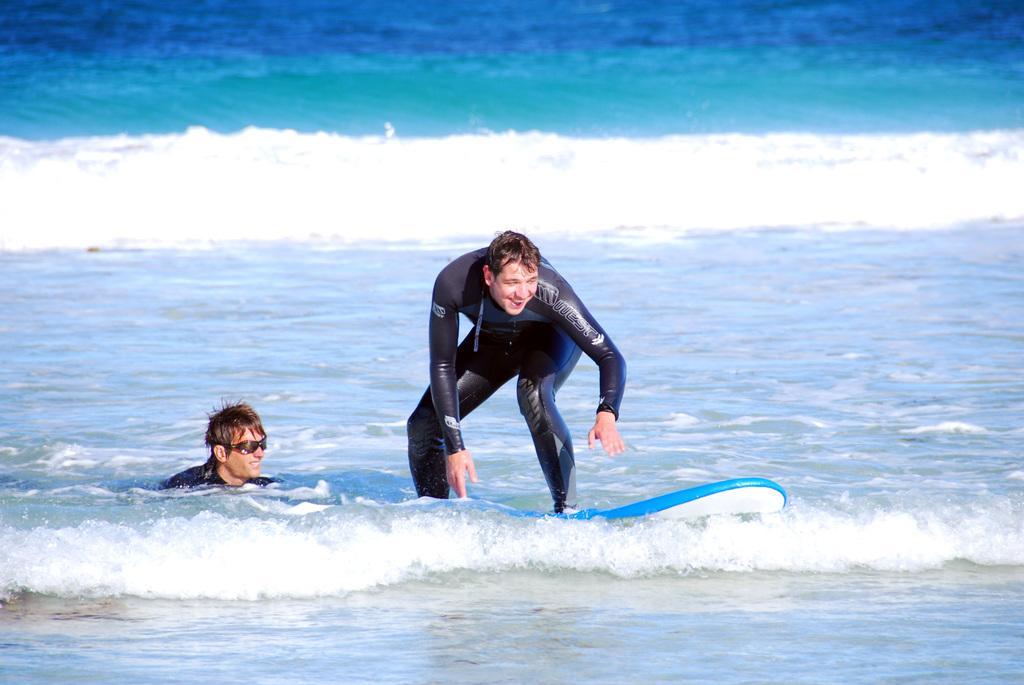How would you summarize this image in a sentence or two? In this picture there are two men, among them one man surfing on the water with surfboard. 